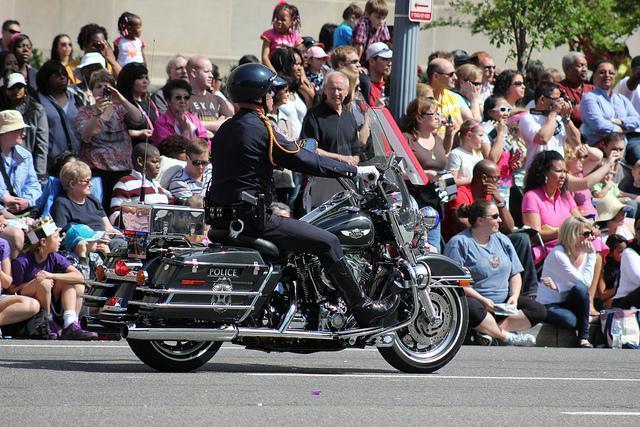Why is the crown worn here?
Select the accurate answer and provide justification: `Answer: choice
Rationale: srationale.`
Options: He's royalty, heir apparent, for fun, imposter. Answer: for fun.
Rationale: The person is wearing a crown because they are having fun at the parade. 